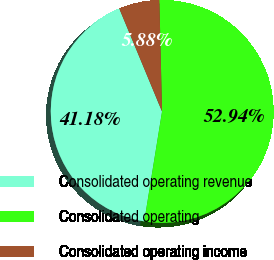<chart> <loc_0><loc_0><loc_500><loc_500><pie_chart><fcel>Consolidated operating revenue<fcel>Consolidated operating<fcel>Consolidated operating income<nl><fcel>41.18%<fcel>52.94%<fcel>5.88%<nl></chart> 